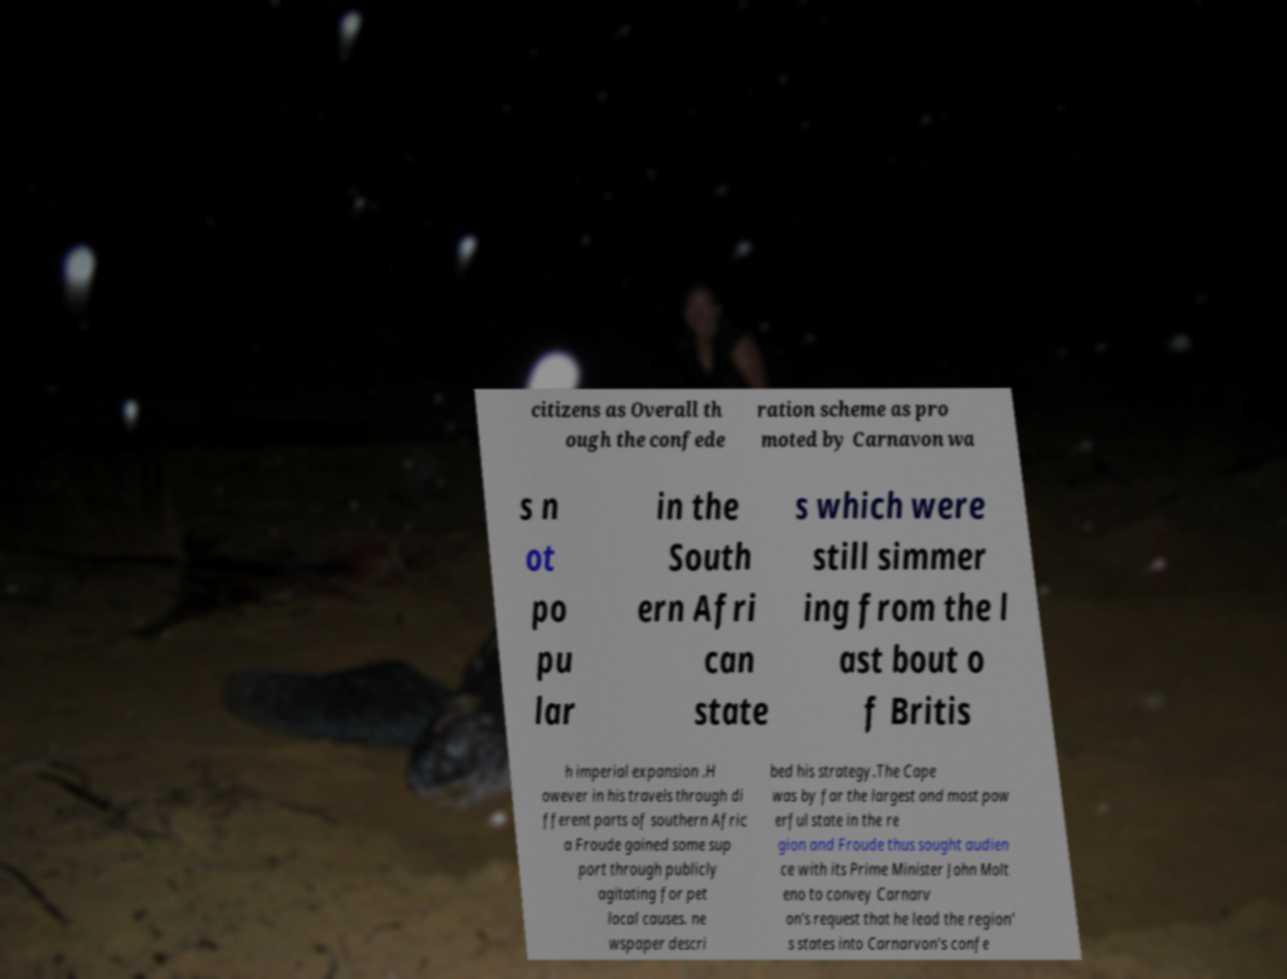I need the written content from this picture converted into text. Can you do that? citizens as Overall th ough the confede ration scheme as pro moted by Carnavon wa s n ot po pu lar in the South ern Afri can state s which were still simmer ing from the l ast bout o f Britis h imperial expansion .H owever in his travels through di fferent parts of southern Afric a Froude gained some sup port through publicly agitating for pet local causes. ne wspaper descri bed his strategy.The Cape was by far the largest and most pow erful state in the re gion and Froude thus sought audien ce with its Prime Minister John Molt eno to convey Carnarv on's request that he lead the region' s states into Carnarvon's confe 